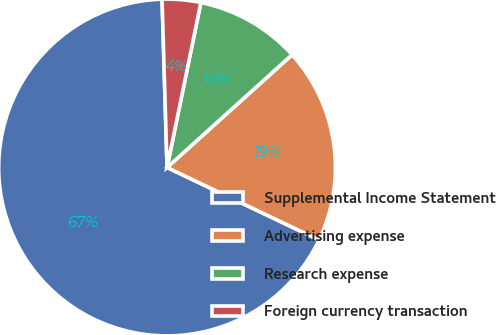Convert chart to OTSL. <chart><loc_0><loc_0><loc_500><loc_500><pie_chart><fcel>Supplemental Income Statement<fcel>Advertising expense<fcel>Research expense<fcel>Foreign currency transaction<nl><fcel>67.44%<fcel>18.76%<fcel>10.1%<fcel>3.69%<nl></chart> 